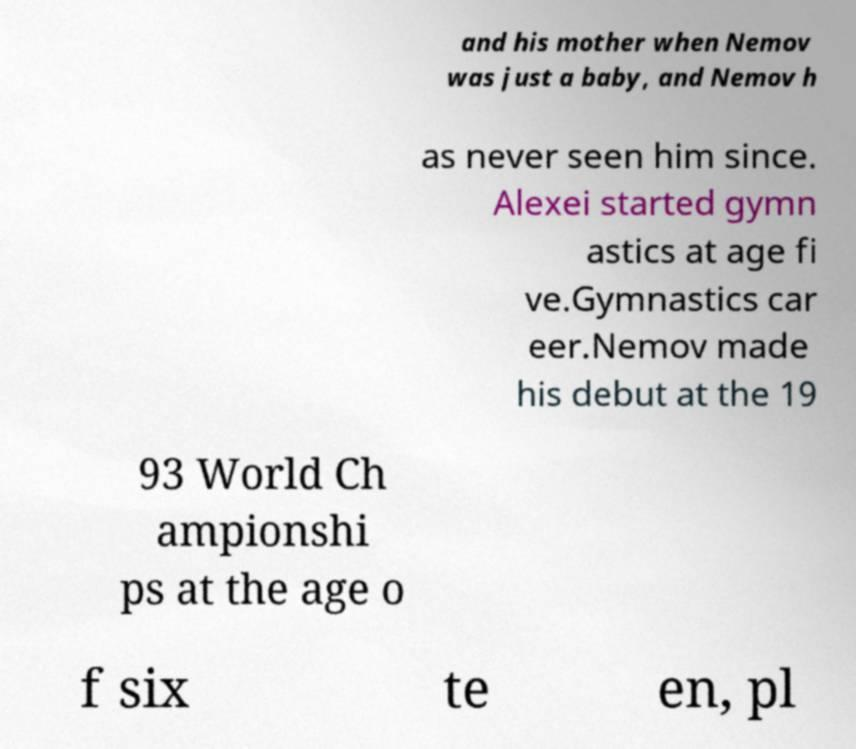Please identify and transcribe the text found in this image. and his mother when Nemov was just a baby, and Nemov h as never seen him since. Alexei started gymn astics at age fi ve.Gymnastics car eer.Nemov made his debut at the 19 93 World Ch ampionshi ps at the age o f six te en, pl 